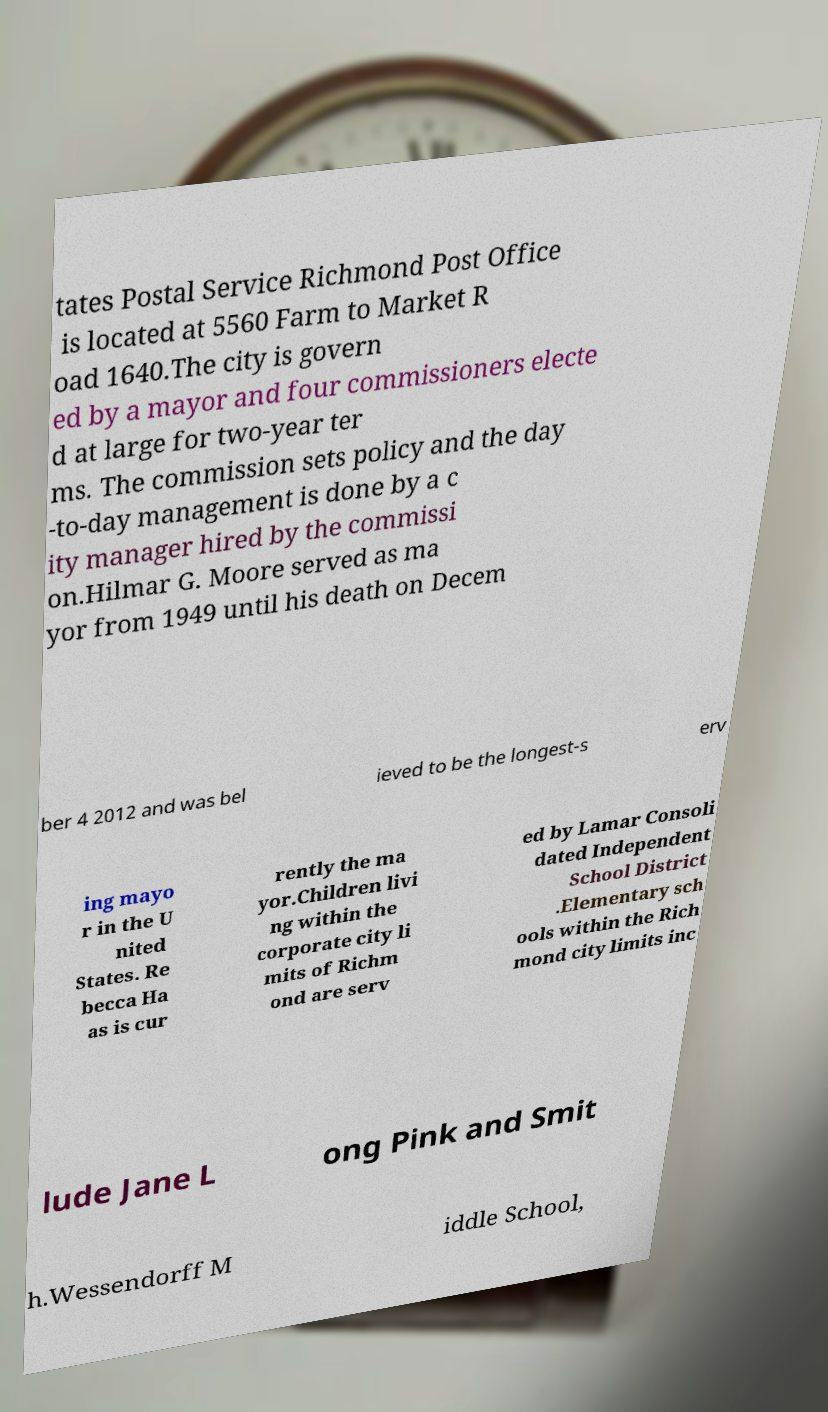Please read and relay the text visible in this image. What does it say? tates Postal Service Richmond Post Office is located at 5560 Farm to Market R oad 1640.The city is govern ed by a mayor and four commissioners electe d at large for two-year ter ms. The commission sets policy and the day -to-day management is done by a c ity manager hired by the commissi on.Hilmar G. Moore served as ma yor from 1949 until his death on Decem ber 4 2012 and was bel ieved to be the longest-s erv ing mayo r in the U nited States. Re becca Ha as is cur rently the ma yor.Children livi ng within the corporate city li mits of Richm ond are serv ed by Lamar Consoli dated Independent School District .Elementary sch ools within the Rich mond city limits inc lude Jane L ong Pink and Smit h.Wessendorff M iddle School, 